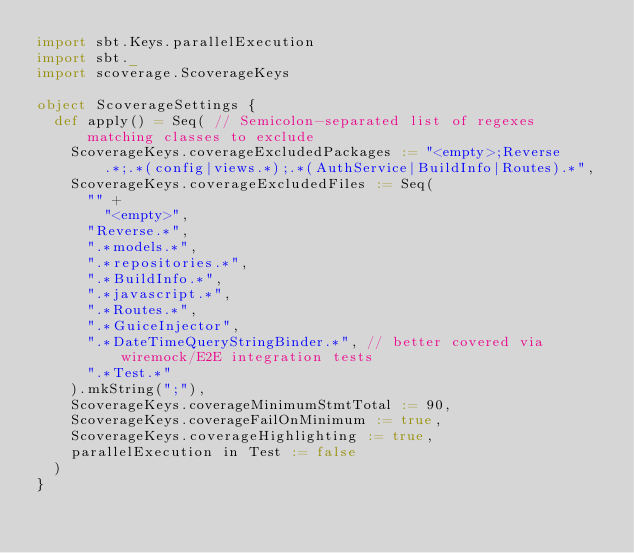<code> <loc_0><loc_0><loc_500><loc_500><_Scala_>import sbt.Keys.parallelExecution
import sbt._
import scoverage.ScoverageKeys

object ScoverageSettings {
  def apply() = Seq( // Semicolon-separated list of regexes matching classes to exclude
    ScoverageKeys.coverageExcludedPackages := "<empty>;Reverse.*;.*(config|views.*);.*(AuthService|BuildInfo|Routes).*",
    ScoverageKeys.coverageExcludedFiles := Seq(
      "" +
        "<empty>",
      "Reverse.*",
      ".*models.*",
      ".*repositories.*",
      ".*BuildInfo.*",
      ".*javascript.*",
      ".*Routes.*",
      ".*GuiceInjector",
      ".*DateTimeQueryStringBinder.*", // better covered via wiremock/E2E integration tests
      ".*Test.*"
    ).mkString(";"),
    ScoverageKeys.coverageMinimumStmtTotal := 90,
    ScoverageKeys.coverageFailOnMinimum := true,
    ScoverageKeys.coverageHighlighting := true,
    parallelExecution in Test := false
  )
}
</code> 